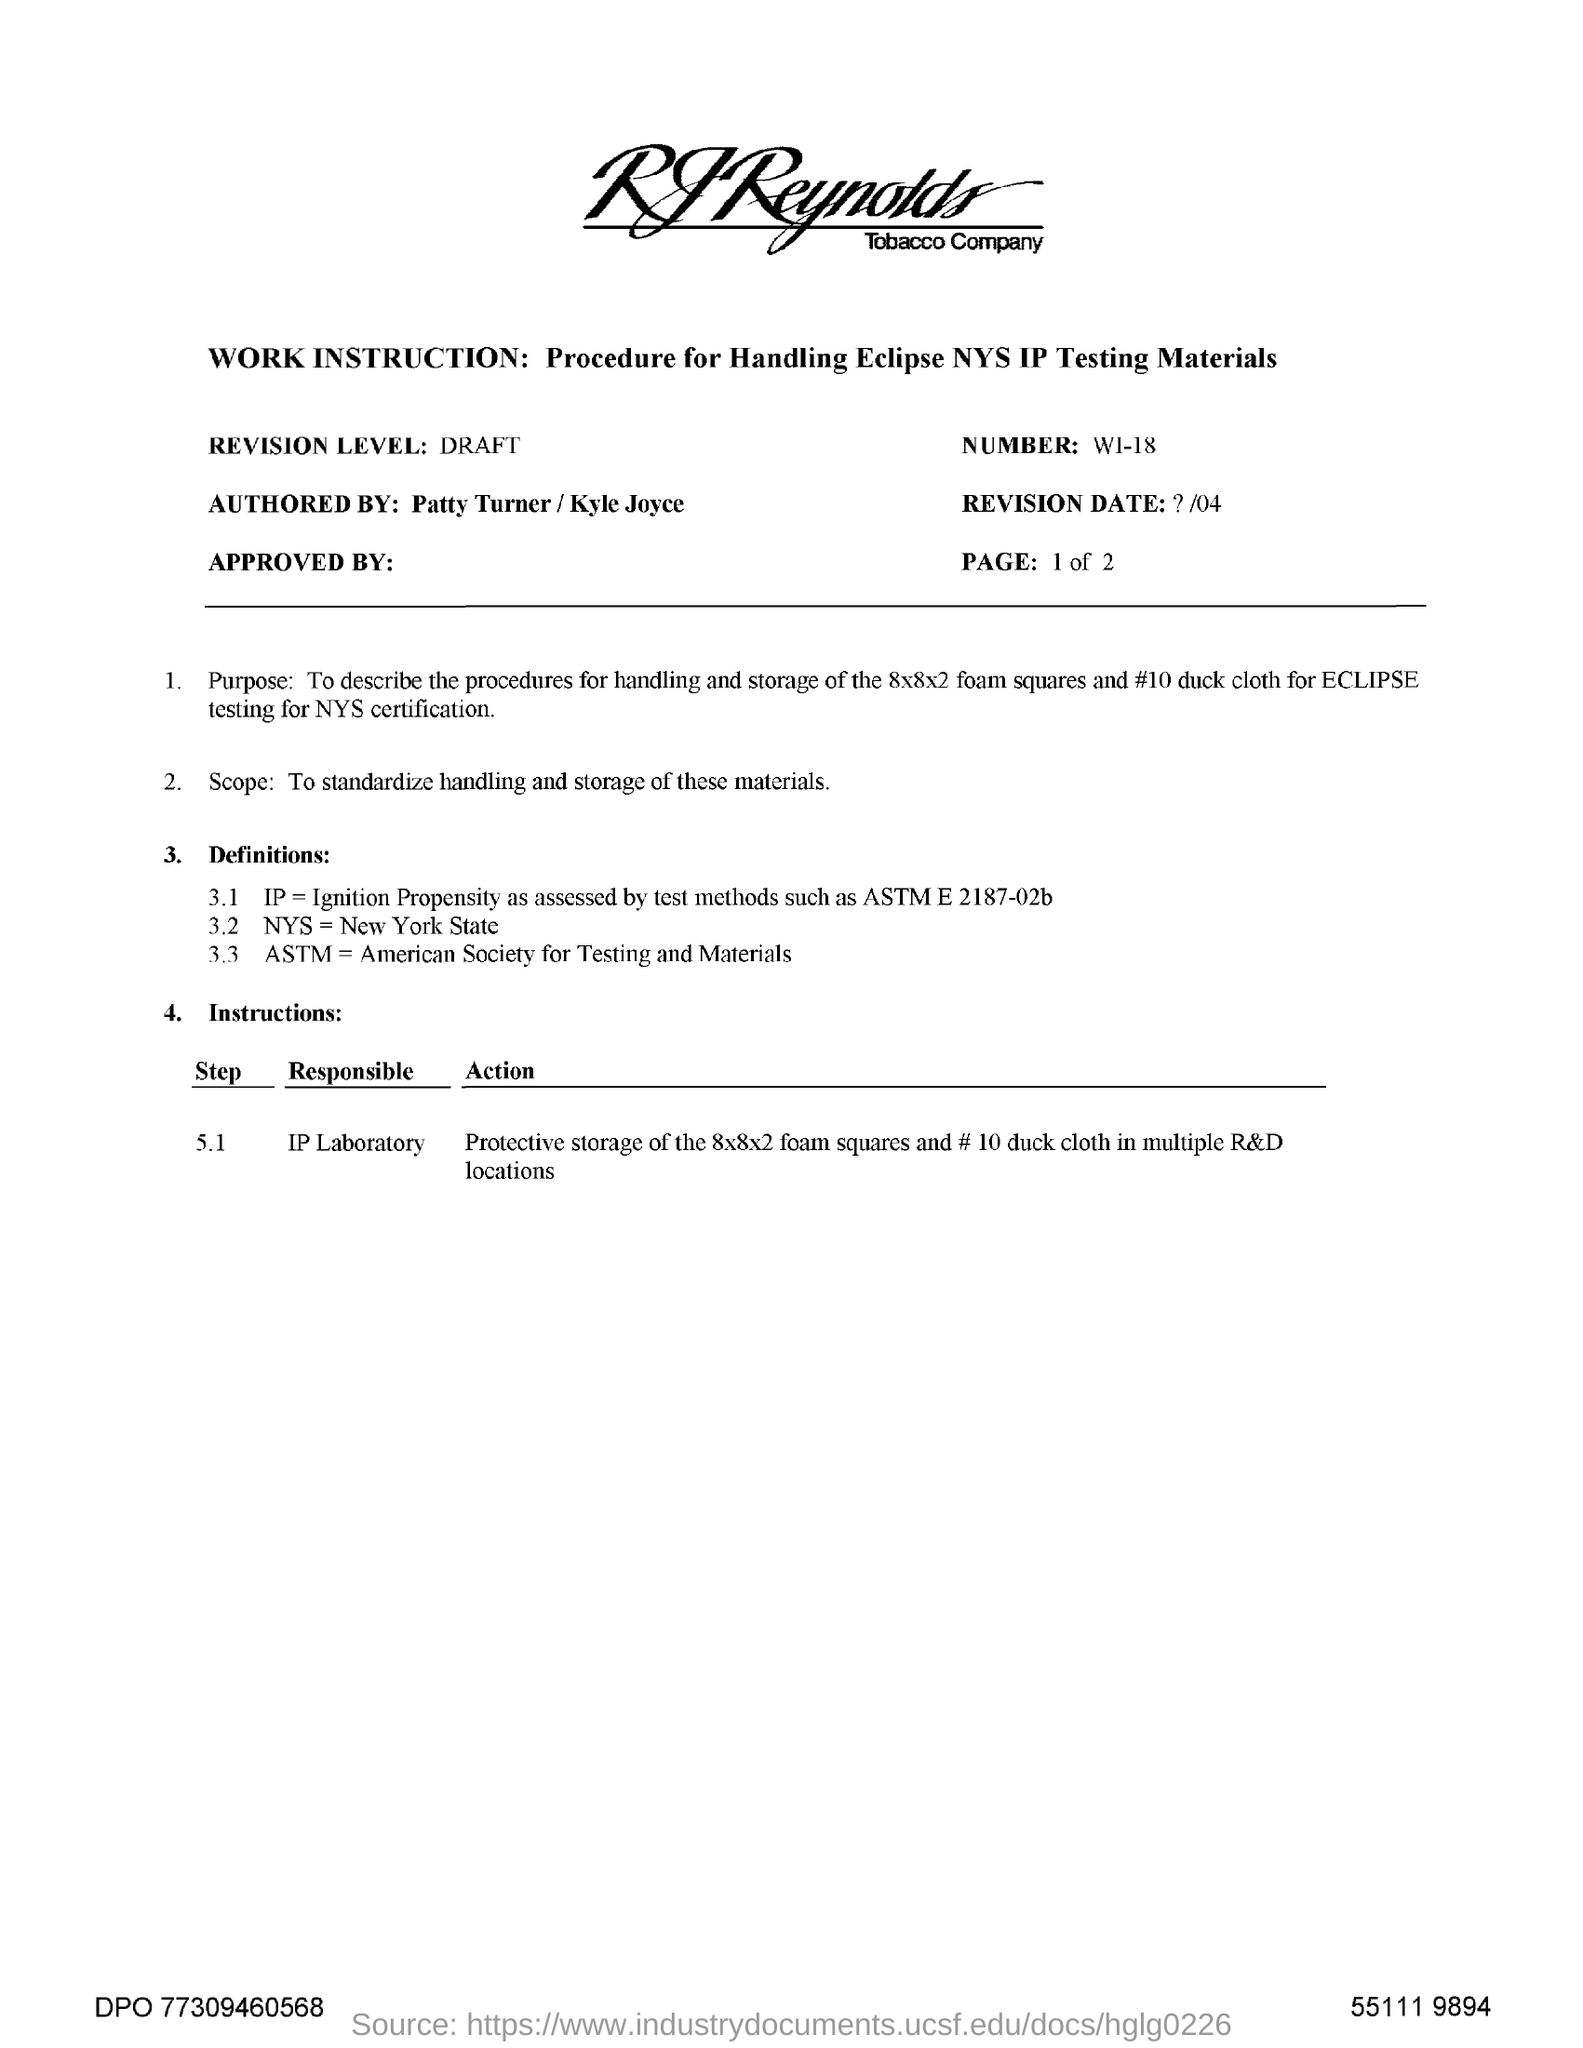What is the revision level mentioned in the document?
Give a very brief answer. DRAFT. What does "NYS" stand for?
Ensure brevity in your answer.  New York State. 